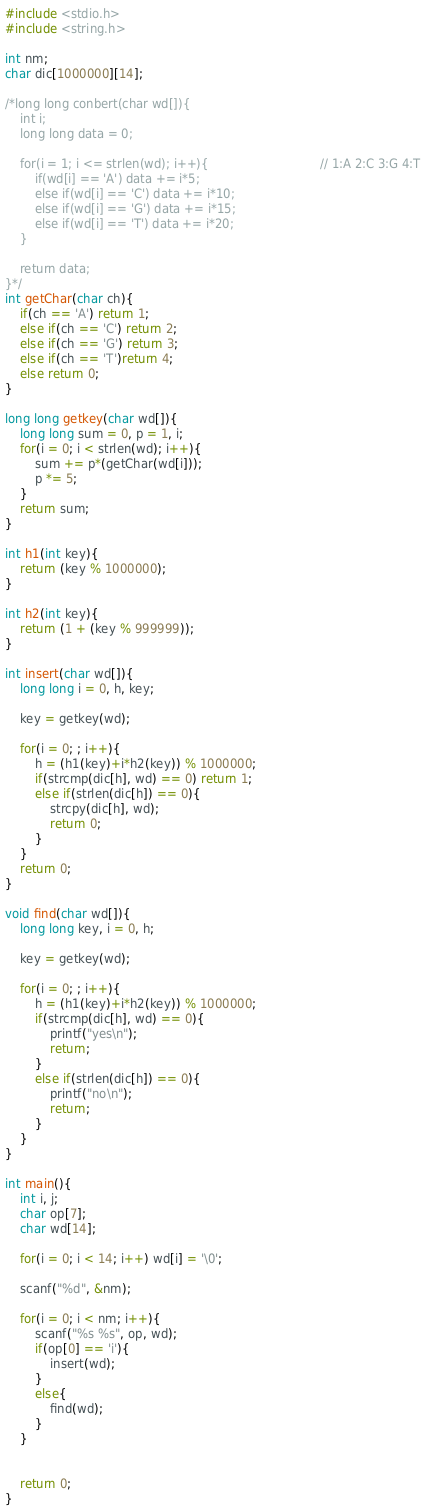Convert code to text. <code><loc_0><loc_0><loc_500><loc_500><_C_>#include <stdio.h>
#include <string.h>

int nm;
char dic[1000000][14];

/*long long conbert(char wd[]){
    int i;
    long long data = 0;

    for(i = 1; i <= strlen(wd); i++){                              // 1:A 2:C 3:G 4:T
        if(wd[i] == 'A') data += i*5;
        else if(wd[i] == 'C') data += i*10;
        else if(wd[i] == 'G') data += i*15;
        else if(wd[i] == 'T') data += i*20;
    }

    return data;
}*/
int getChar(char ch){
    if(ch == 'A') return 1;
    else if(ch == 'C') return 2;
    else if(ch == 'G') return 3;
    else if(ch == 'T')return 4;
    else return 0;
}

long long getkey(char wd[]){
    long long sum = 0, p = 1, i;
    for(i = 0; i < strlen(wd); i++){
        sum += p*(getChar(wd[i]));
        p *= 5;
    }
    return sum;
}

int h1(int key){
    return (key % 1000000);
}

int h2(int key){
    return (1 + (key % 999999));
}

int insert(char wd[]){
    long long i = 0, h, key;

    key = getkey(wd);

    for(i = 0; ; i++){
        h = (h1(key)+i*h2(key)) % 1000000;
        if(strcmp(dic[h], wd) == 0) return 1;
        else if(strlen(dic[h]) == 0){
            strcpy(dic[h], wd);
            return 0;
        }
    }
    return 0;
}

void find(char wd[]){
    long long key, i = 0, h;

    key = getkey(wd);

    for(i = 0; ; i++){
        h = (h1(key)+i*h2(key)) % 1000000;
        if(strcmp(dic[h], wd) == 0){
            printf("yes\n");
            return;
        }
        else if(strlen(dic[h]) == 0){
            printf("no\n");
            return;
        }
    }
}

int main(){
    int i, j;
    char op[7];
    char wd[14];
    
    for(i = 0; i < 14; i++) wd[i] = '\0';

    scanf("%d", &nm);

    for(i = 0; i < nm; i++){
        scanf("%s %s", op, wd);
        if(op[0] == 'i'){
            insert(wd);
        }
        else{
            find(wd);
        }
    }


    return 0;
}
</code> 